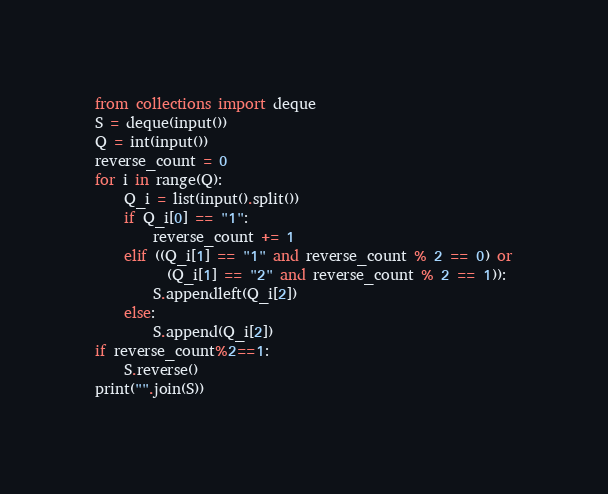Convert code to text. <code><loc_0><loc_0><loc_500><loc_500><_Python_>from collections import deque
S = deque(input())
Q = int(input())
reverse_count = 0
for i in range(Q):
    Q_i = list(input().split())
    if Q_i[0] == "1":
        reverse_count += 1
    elif ((Q_i[1] == "1" and reverse_count % 2 == 0) or
          (Q_i[1] == "2" and reverse_count % 2 == 1)):
        S.appendleft(Q_i[2])
    else:
        S.append(Q_i[2])
if reverse_count%2==1:
    S.reverse()
print("".join(S))</code> 